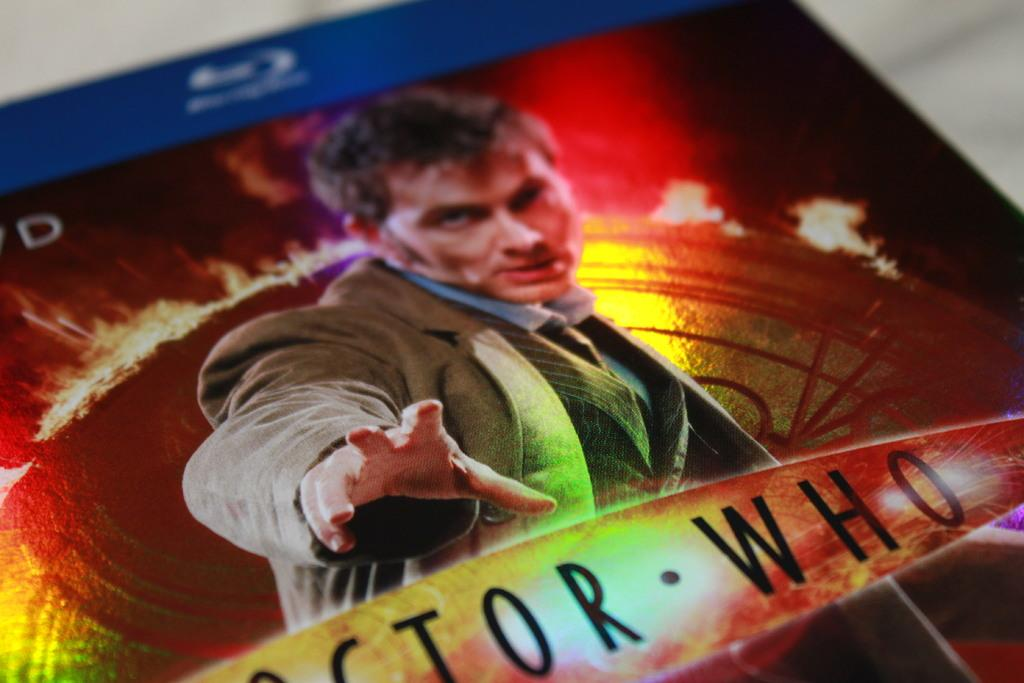<image>
Write a terse but informative summary of the picture. The top part of the Blu Ray disk for Doctor Who. 